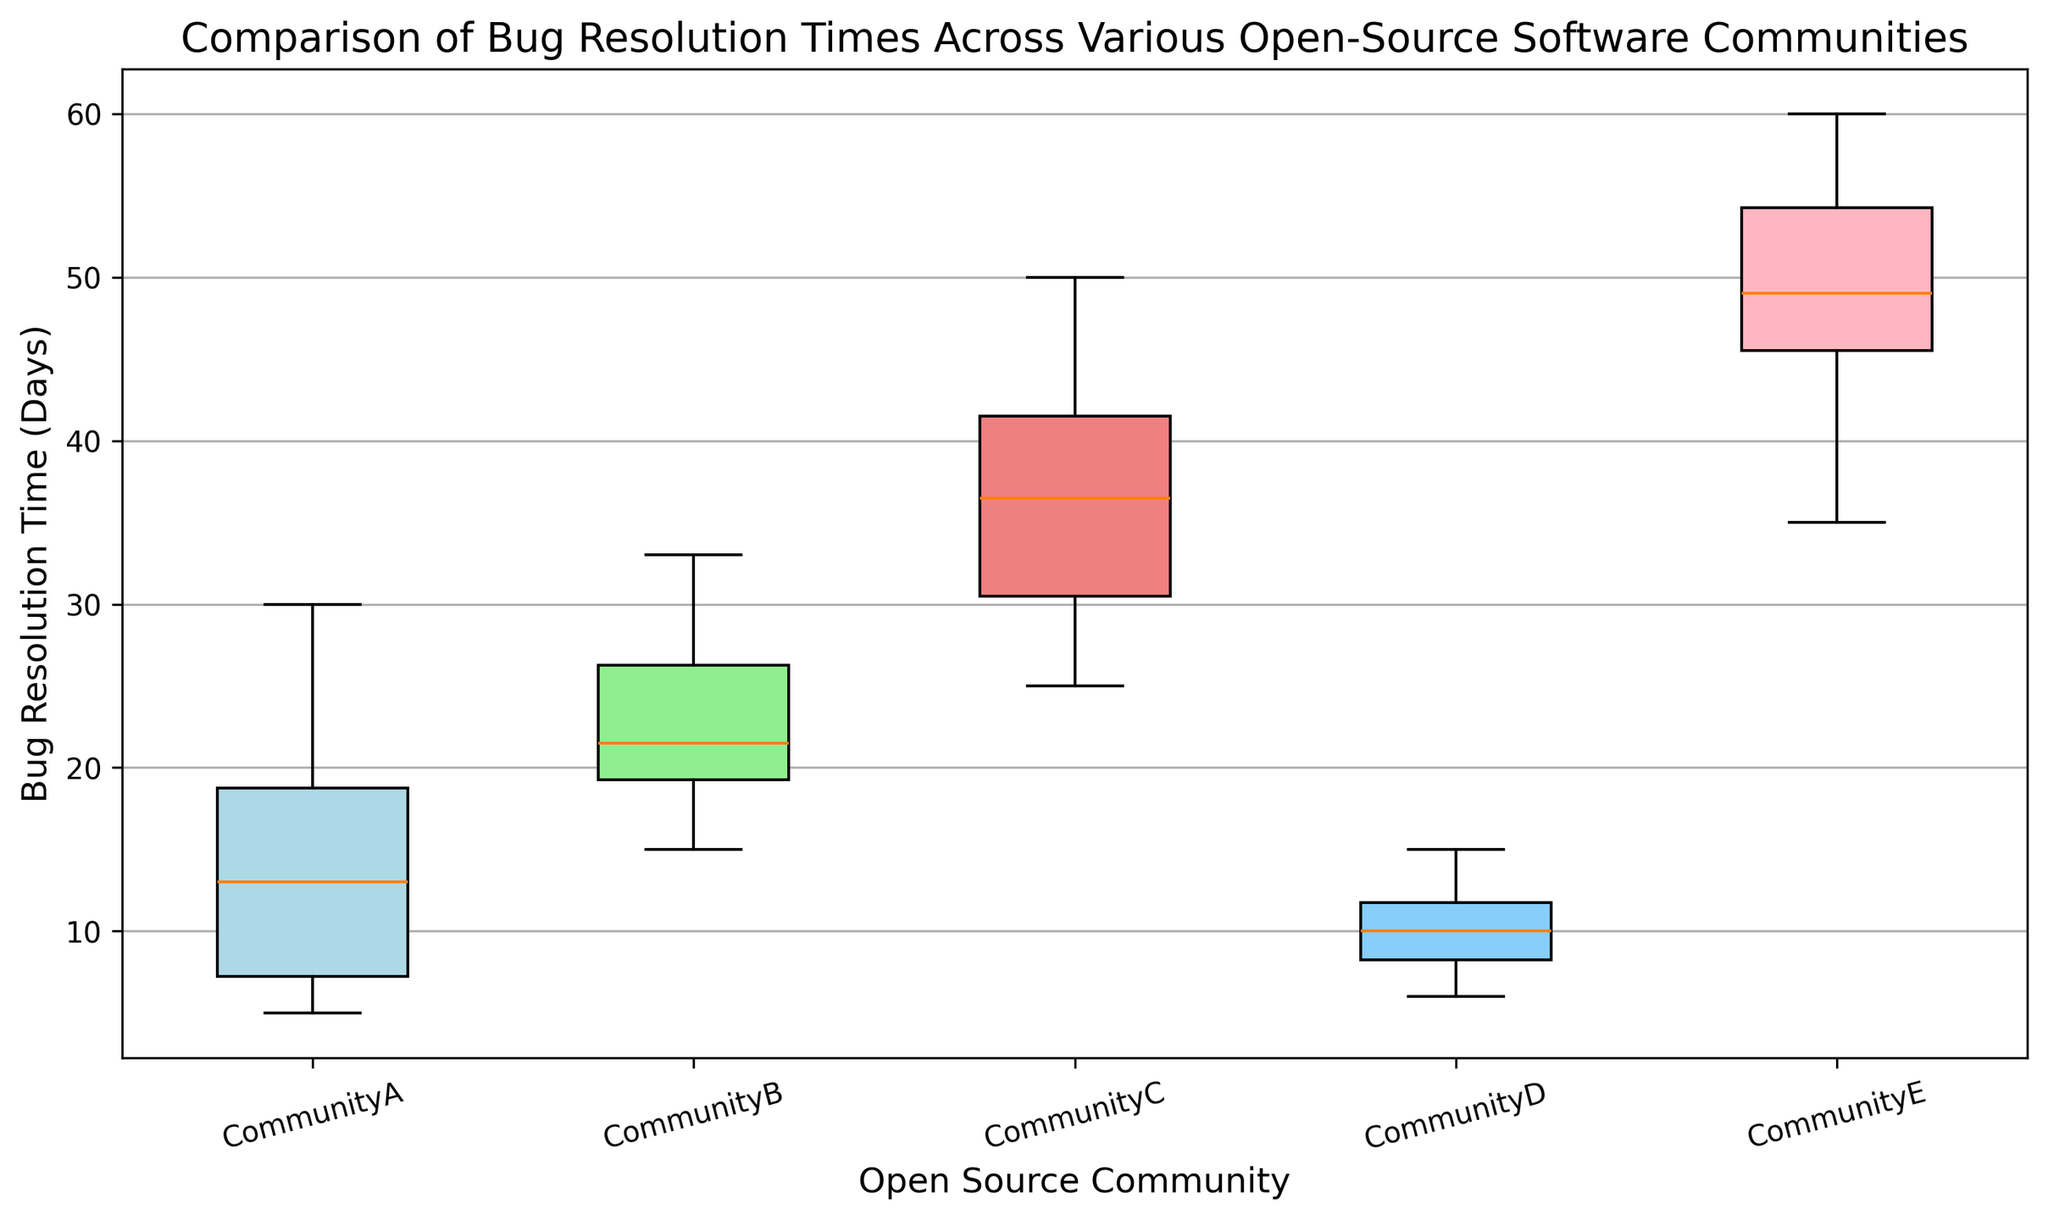Which community has the shortest median bug resolution time? The box plot shows the median as a line within each box. By observing the median lines, Community D has the shortest median bug resolution time.
Answer: Community D Which community has the longest whisker on the upper end? Whiskers represent the range of the data beyond the 1st and 3rd quartiles. The box plot with the longest upper whisker appears to be Community E.
Answer: Community E What's the difference between the median bug resolution times of Community A and Community C? Community A has a median approximately at 14 days and Community C has a median at 40 days. The difference is 40 - 14 = 26 days.
Answer: 26 days Which community has the widest interquartile range (IQR) of bug resolution times? The IQR is the length of the box. Comparing the lengths of the boxes, Community E has the widest IQR.
Answer: Community E Which communities have outliers in their bug resolution times? Outliers are represented as individual points outside of the whiskers. According to the plot, none of the communities have visible outliers.
Answer: None How does the IQR of Community B compare to that of Community D? Community B's IQR (box length) is larger than Community D's. Community D’s box is relatively shorter compared to Community B's.
Answer: Community B has a larger IQR What's the approximate maximum bug resolution time for Community A? The maximum is indicated by the length of the upper whisker. For Community A, it appears to be around 30 days.
Answer: 30 days Which community has the most consistent (least variable) bug resolution times? Consistency is indicated by the smallest IQR and whiskers. Community D has the smallest range and IQR, indicating the most consistent bug resolution times.
Answer: Community D Compare the bug resolution times of Community C and Community E. Which has higher values on average and why? Community E’s median, box length, and whiskers are all higher than those of Community C. This indicates that Community E generally has higher bug resolution times.
Answer: Community E What is the interquartile range (IQR) for Community C? The IQR is the difference between the 3rd quartile and the 1st quartile. From the plot, estimate the 3rd quartile to be around 45 days and the 1st quartile around 30 days. Therefore, the IQR is 45 - 30 = 15 days.
Answer: 15 days 